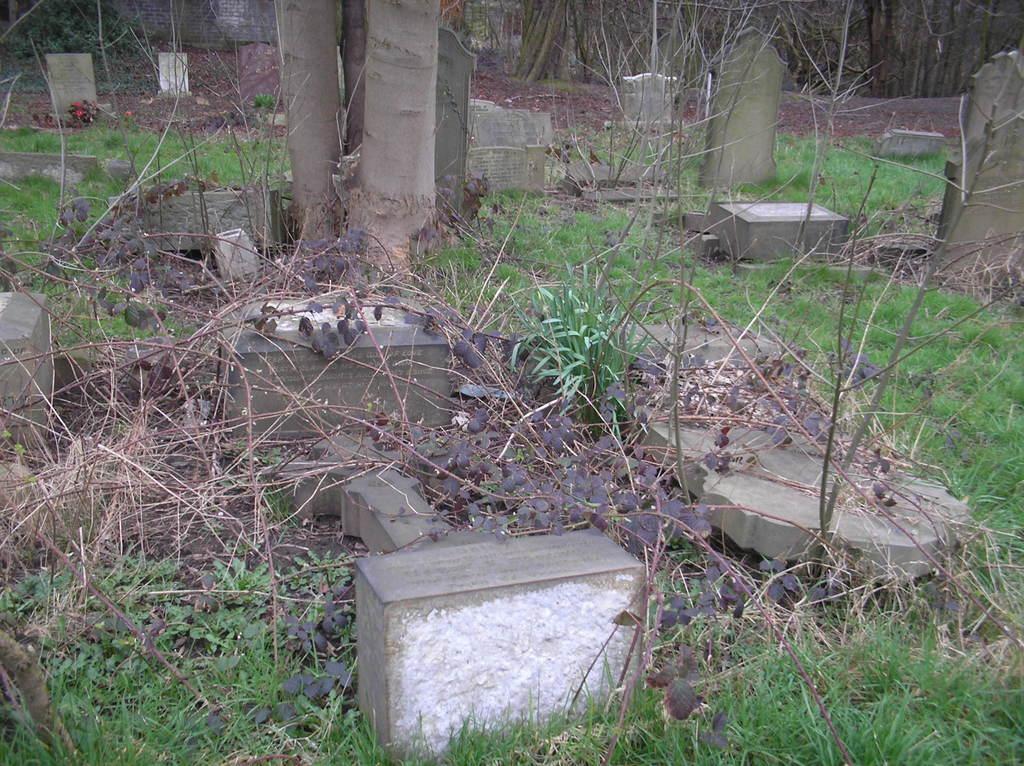Describe this image in one or two sentences. The picture is taken in a cemetery. In this picture there are plants, trees, grass and gravestones. At the top there are trees. 